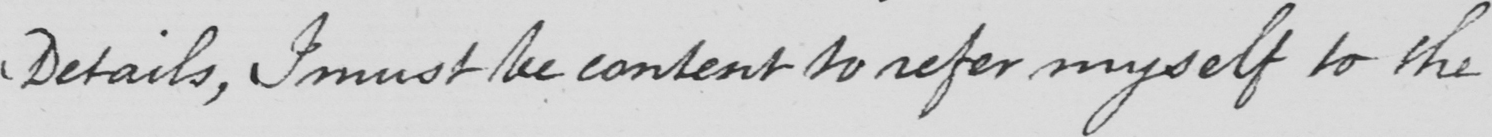Please transcribe the handwritten text in this image. Details , I must be content to refer myself to the 